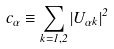Convert formula to latex. <formula><loc_0><loc_0><loc_500><loc_500>c _ { \alpha } \equiv \sum _ { k = 1 , 2 } | U _ { { \alpha } k } | ^ { 2 }</formula> 